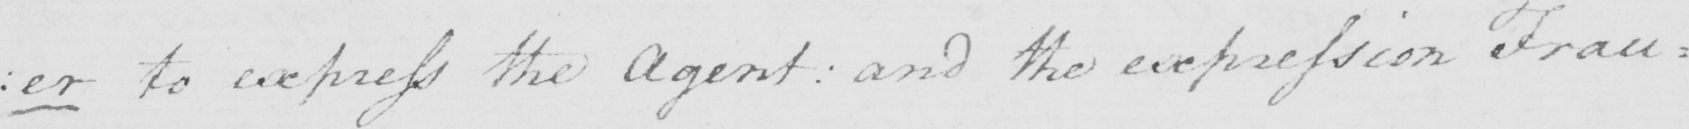Can you tell me what this handwritten text says? : er to express the Agent :  and the expression Frau= 